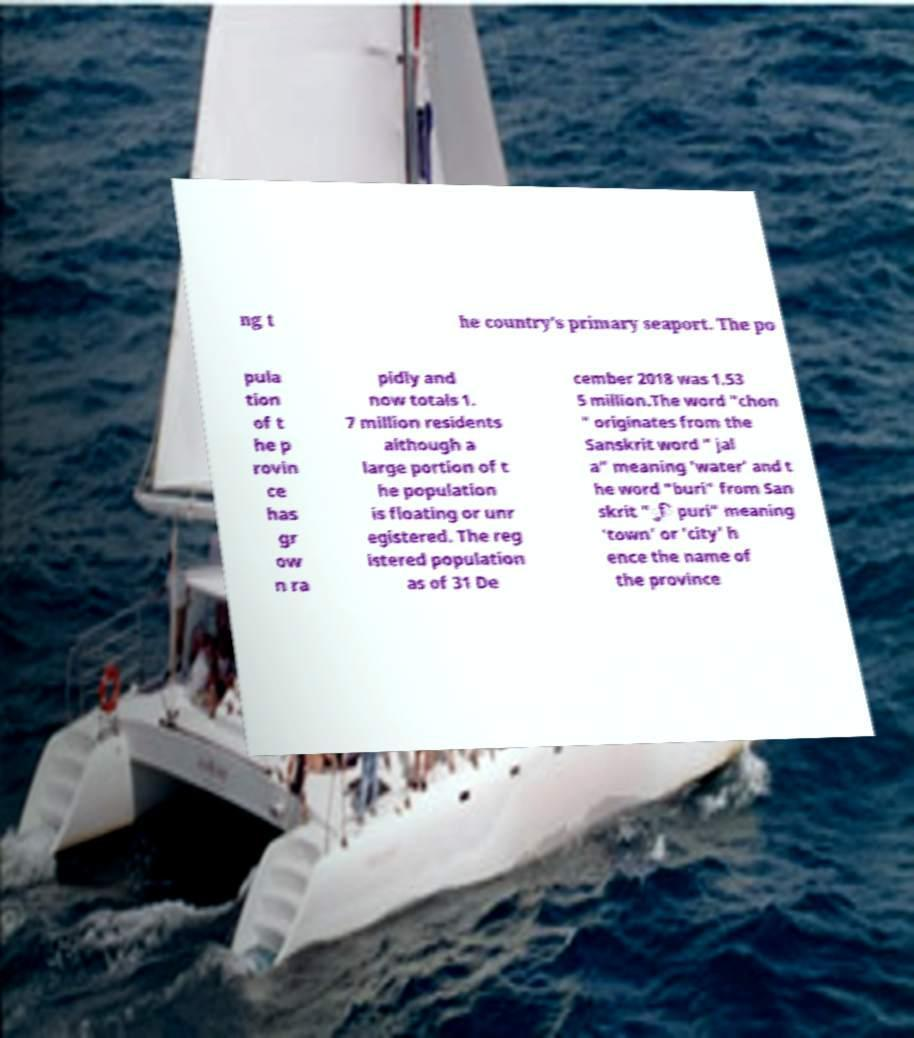Can you accurately transcribe the text from the provided image for me? ng t he country's primary seaport. The po pula tion of t he p rovin ce has gr ow n ra pidly and now totals 1. 7 million residents although a large portion of t he population is floating or unr egistered. The reg istered population as of 31 De cember 2018 was 1.53 5 million.The word "chon " originates from the Sanskrit word " jal a" meaning 'water' and t he word "buri" from San skrit "ुि puri" meaning 'town' or 'city' h ence the name of the province 